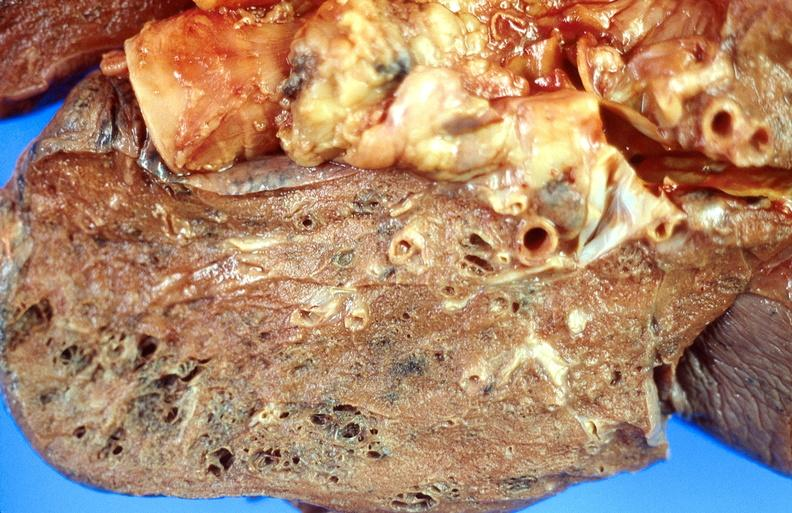where is this?
Answer the question using a single word or phrase. Lung 